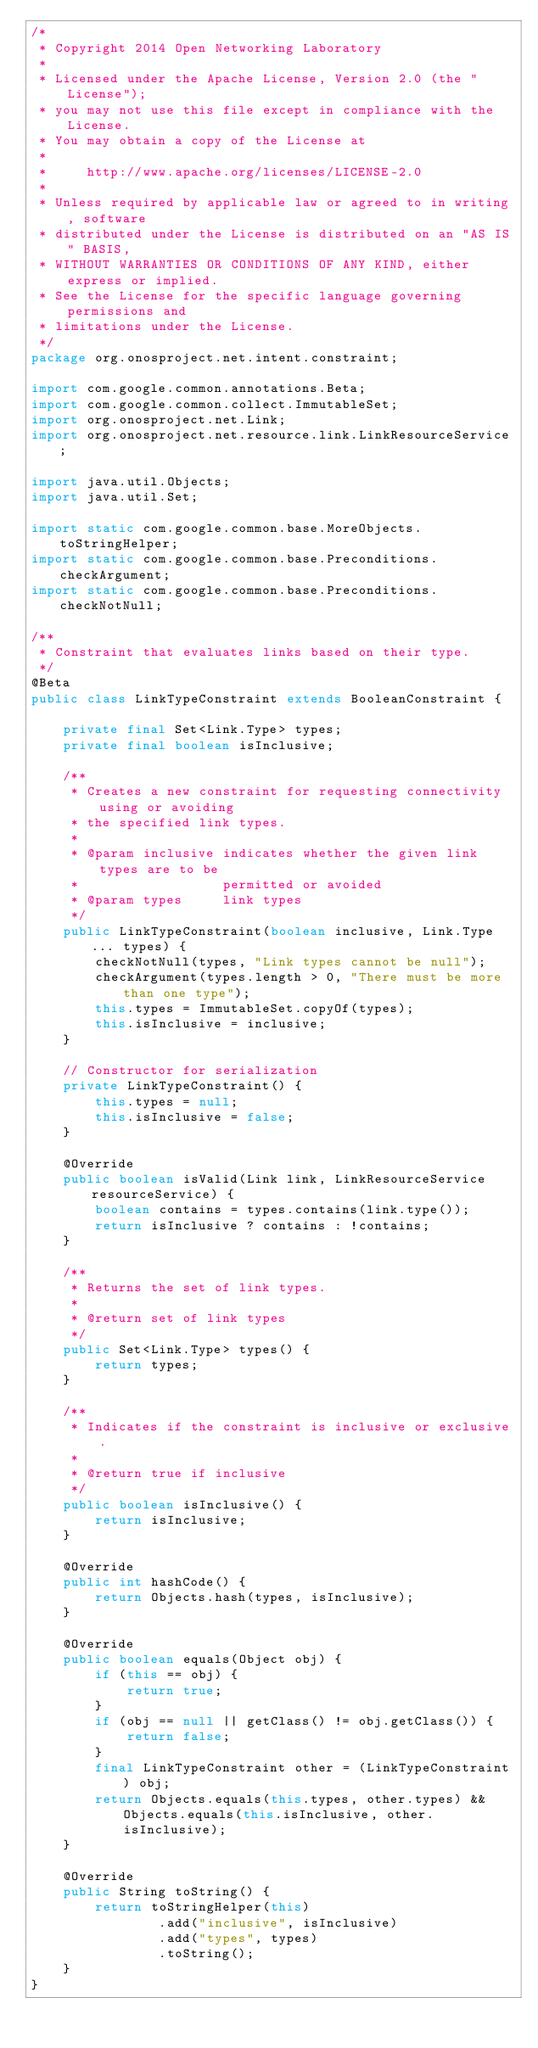<code> <loc_0><loc_0><loc_500><loc_500><_Java_>/*
 * Copyright 2014 Open Networking Laboratory
 *
 * Licensed under the Apache License, Version 2.0 (the "License");
 * you may not use this file except in compliance with the License.
 * You may obtain a copy of the License at
 *
 *     http://www.apache.org/licenses/LICENSE-2.0
 *
 * Unless required by applicable law or agreed to in writing, software
 * distributed under the License is distributed on an "AS IS" BASIS,
 * WITHOUT WARRANTIES OR CONDITIONS OF ANY KIND, either express or implied.
 * See the License for the specific language governing permissions and
 * limitations under the License.
 */
package org.onosproject.net.intent.constraint;

import com.google.common.annotations.Beta;
import com.google.common.collect.ImmutableSet;
import org.onosproject.net.Link;
import org.onosproject.net.resource.link.LinkResourceService;

import java.util.Objects;
import java.util.Set;

import static com.google.common.base.MoreObjects.toStringHelper;
import static com.google.common.base.Preconditions.checkArgument;
import static com.google.common.base.Preconditions.checkNotNull;

/**
 * Constraint that evaluates links based on their type.
 */
@Beta
public class LinkTypeConstraint extends BooleanConstraint {

    private final Set<Link.Type> types;
    private final boolean isInclusive;

    /**
     * Creates a new constraint for requesting connectivity using or avoiding
     * the specified link types.
     *
     * @param inclusive indicates whether the given link types are to be
     *                  permitted or avoided
     * @param types     link types
     */
    public LinkTypeConstraint(boolean inclusive, Link.Type... types) {
        checkNotNull(types, "Link types cannot be null");
        checkArgument(types.length > 0, "There must be more than one type");
        this.types = ImmutableSet.copyOf(types);
        this.isInclusive = inclusive;
    }

    // Constructor for serialization
    private LinkTypeConstraint() {
        this.types = null;
        this.isInclusive = false;
    }

    @Override
    public boolean isValid(Link link, LinkResourceService resourceService) {
        boolean contains = types.contains(link.type());
        return isInclusive ? contains : !contains;
    }

    /**
     * Returns the set of link types.
     *
     * @return set of link types
     */
    public Set<Link.Type> types() {
        return types;
    }

    /**
     * Indicates if the constraint is inclusive or exclusive.
     *
     * @return true if inclusive
     */
    public boolean isInclusive() {
        return isInclusive;
    }

    @Override
    public int hashCode() {
        return Objects.hash(types, isInclusive);
    }

    @Override
    public boolean equals(Object obj) {
        if (this == obj) {
            return true;
        }
        if (obj == null || getClass() != obj.getClass()) {
            return false;
        }
        final LinkTypeConstraint other = (LinkTypeConstraint) obj;
        return Objects.equals(this.types, other.types) && Objects.equals(this.isInclusive, other.isInclusive);
    }

    @Override
    public String toString() {
        return toStringHelper(this)
                .add("inclusive", isInclusive)
                .add("types", types)
                .toString();
    }
}
</code> 